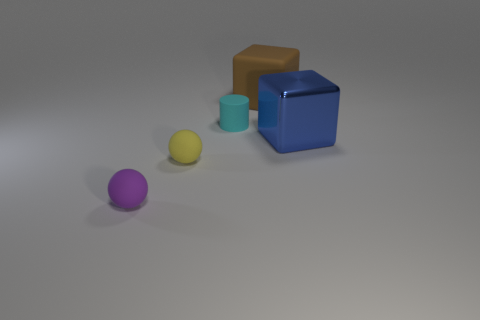Add 4 large brown cubes. How many objects exist? 9 Subtract all purple balls. How many balls are left? 1 Subtract all brown cubes. How many yellow spheres are left? 1 Subtract 2 blocks. How many blocks are left? 0 Subtract all blue blocks. Subtract all brown spheres. How many blocks are left? 1 Subtract all big purple blocks. Subtract all tiny yellow rubber spheres. How many objects are left? 4 Add 4 tiny purple objects. How many tiny purple objects are left? 5 Add 2 cyan cylinders. How many cyan cylinders exist? 3 Subtract 0 brown cylinders. How many objects are left? 5 Subtract all blocks. How many objects are left? 3 